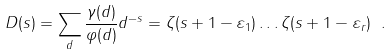Convert formula to latex. <formula><loc_0><loc_0><loc_500><loc_500>D ( s ) = \sum _ { d } \frac { \gamma ( d ) } { \varphi ( d ) } d ^ { - s } = \zeta ( s + 1 - \varepsilon _ { 1 } ) \dots \zeta ( s + 1 - \varepsilon _ { r } ) \ .</formula> 